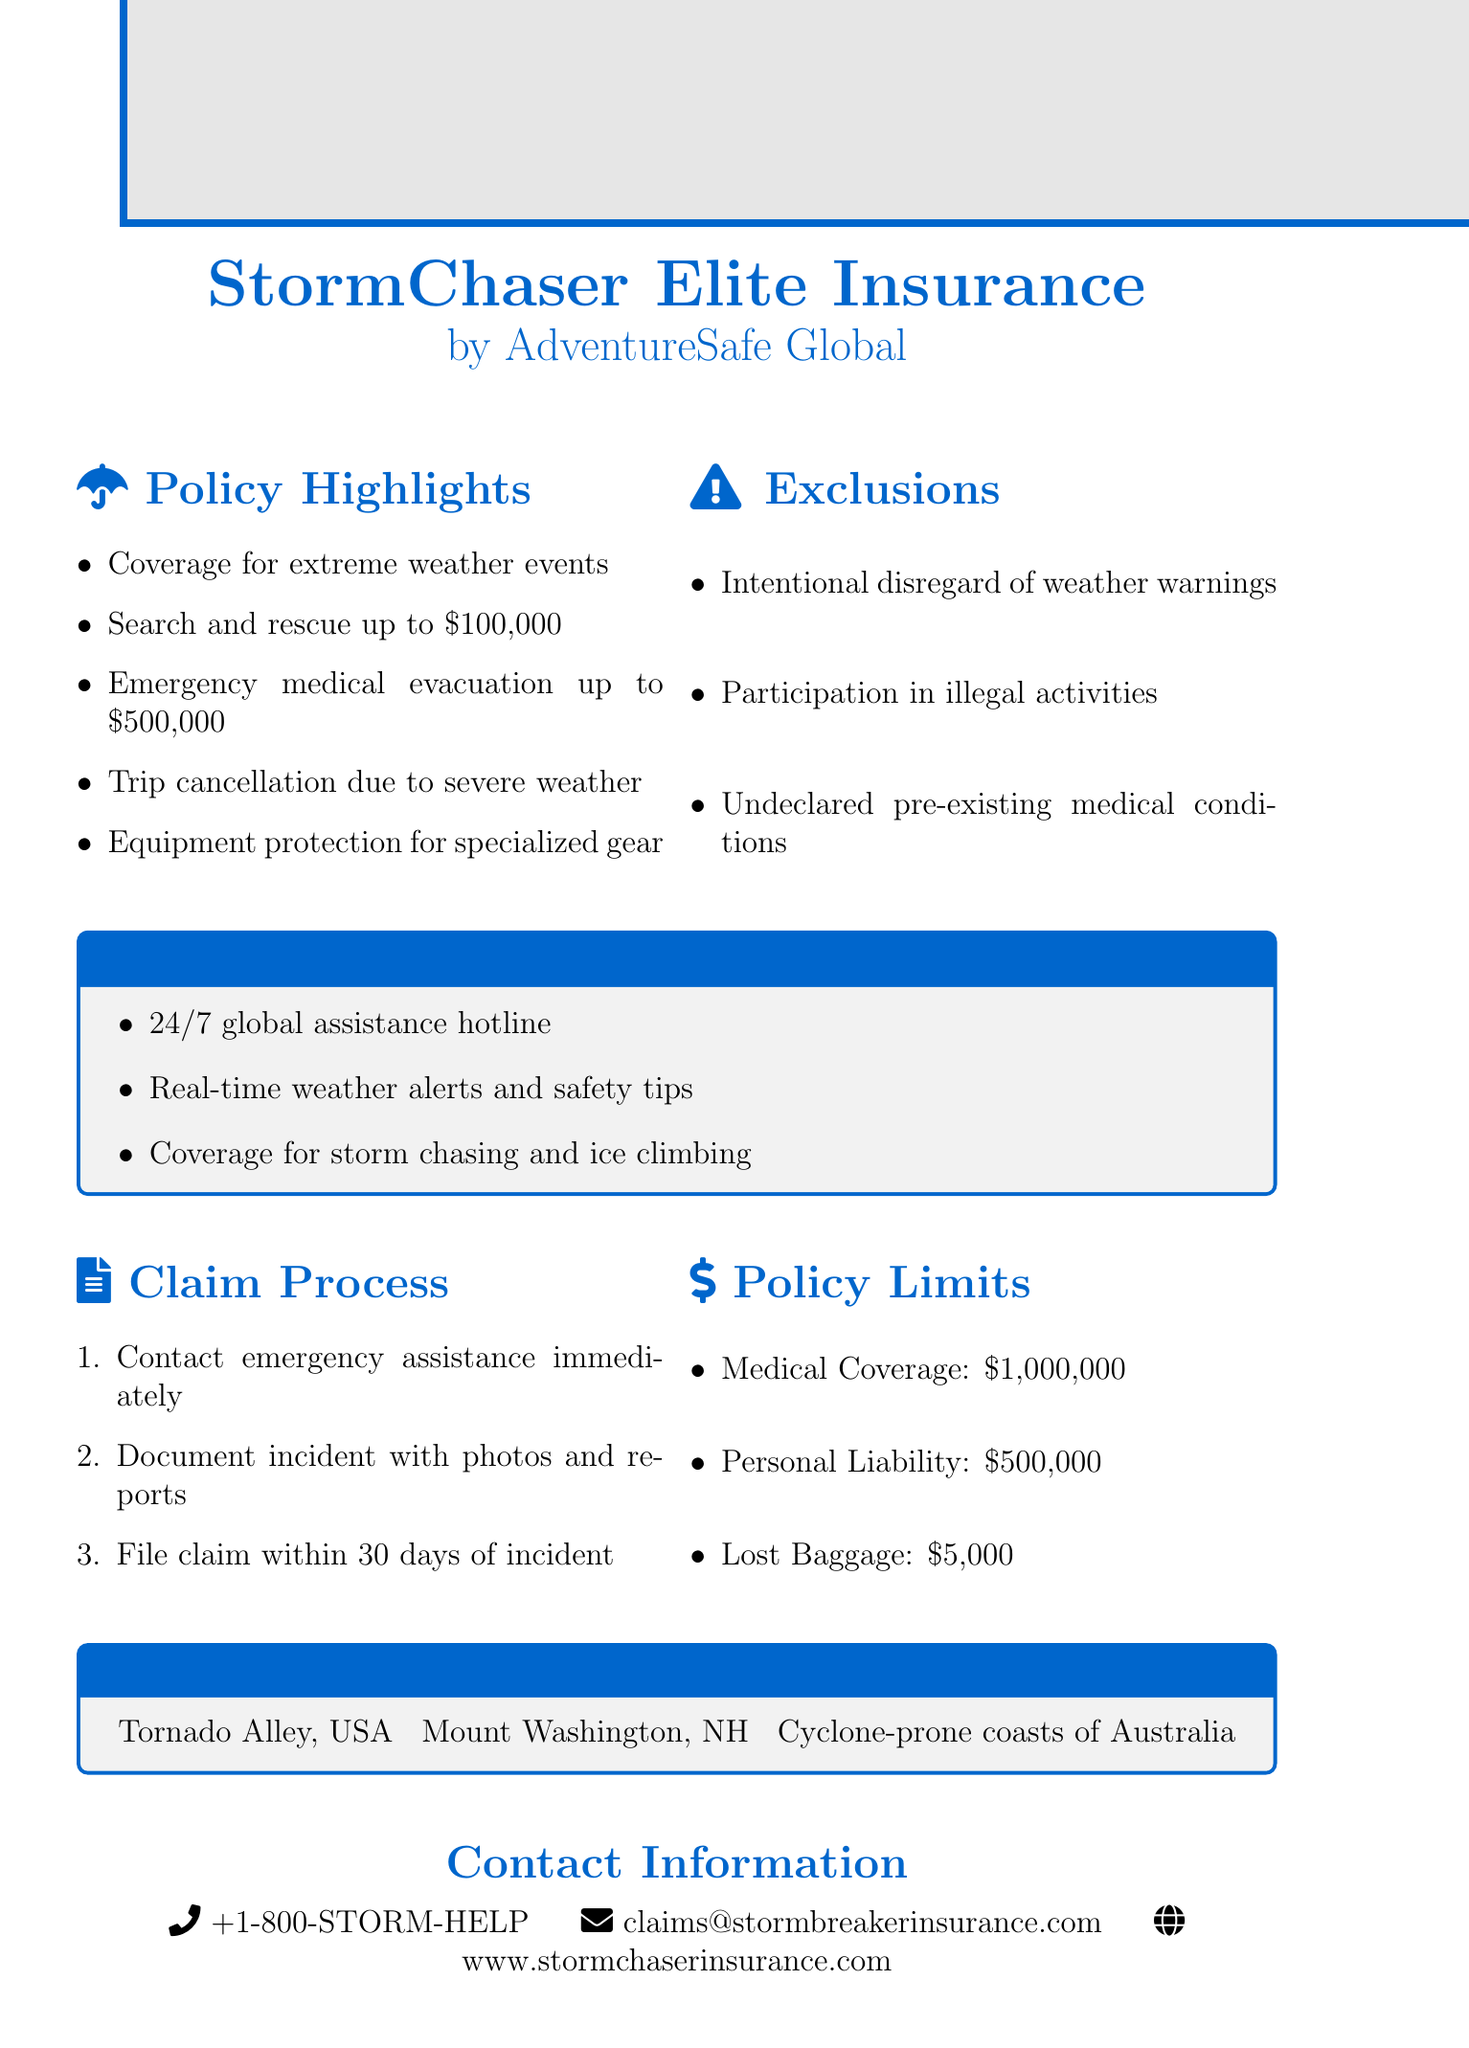What is the name of the insurance policy? The name of the insurance policy is stated in the document as "StormChaser Elite Insurance."
Answer: StormChaser Elite Insurance Who is the insurance provider? The insurance provider is mentioned clearly in the document as "AdventureSafe Global."
Answer: AdventureSafe Global What is the maximum coverage for emergency medical evacuation? This amount is specified as "$500,000" in the policy limits section.
Answer: $500,000 What are the exclusions related to activities? The exclusions include intentional disregard of official weather warnings, among others, indicating prohibited activities.
Answer: Intentional disregard of official weather warnings What is the claim filing timeframe after an incident? The document specifies that claims must be filed within "30 days of incident."
Answer: 30 days Which extreme weather events are covered? The policy highlights mention coverage for hurricanes, tornadoes, and blizzards as extreme weather events.
Answer: Hurricanes, tornadoes, and blizzards What type of hotline is provided in the special features? The document notes a "24/7 global assistance hotline" as a feature.
Answer: 24/7 global assistance hotline How much is covered for lost baggage? The document states that lost baggage coverage is "$5,000."
Answer: $5,000 List one recommended destination for this insurance policy? The document mentions "Tornado Alley, USA" as one of the recommended destinations.
Answer: Tornado Alley, USA 